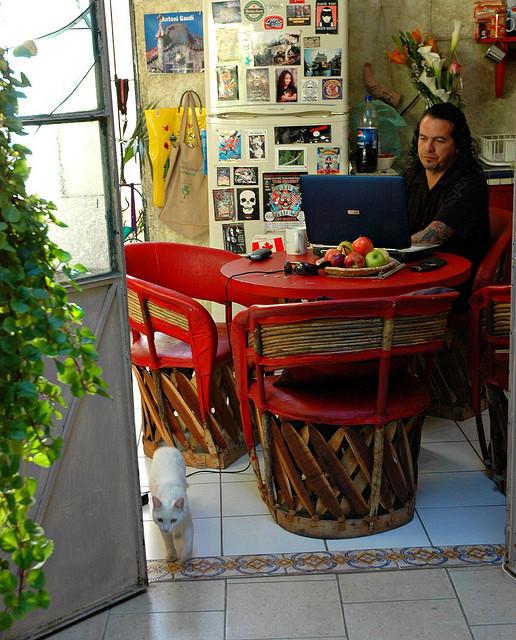What color is the cat?
Concise answer only. White. Is the man sitting in a cafe?
Write a very short answer. No. What sound does the cat make?
Short answer required. Meow. 